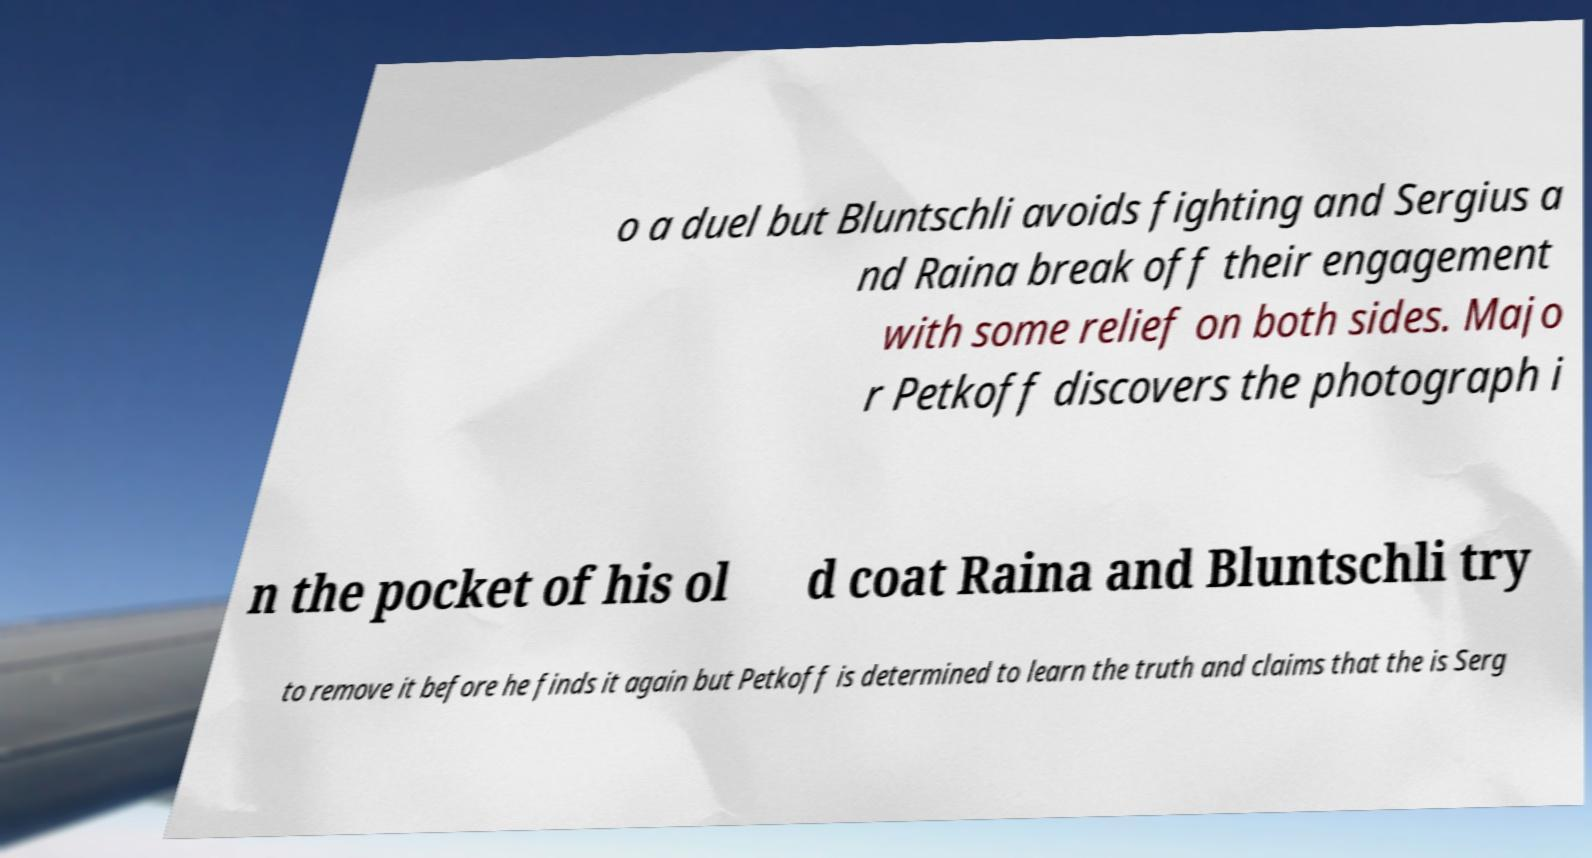Please identify and transcribe the text found in this image. o a duel but Bluntschli avoids fighting and Sergius a nd Raina break off their engagement with some relief on both sides. Majo r Petkoff discovers the photograph i n the pocket of his ol d coat Raina and Bluntschli try to remove it before he finds it again but Petkoff is determined to learn the truth and claims that the is Serg 